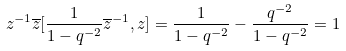<formula> <loc_0><loc_0><loc_500><loc_500>z ^ { - 1 } \overline { z } [ \frac { 1 } { 1 - q ^ { - 2 } } \overline { z } ^ { - 1 } , z ] = \frac { 1 } { 1 - q ^ { - 2 } } - \frac { q ^ { - 2 } } { 1 - q ^ { - 2 } } = 1</formula> 